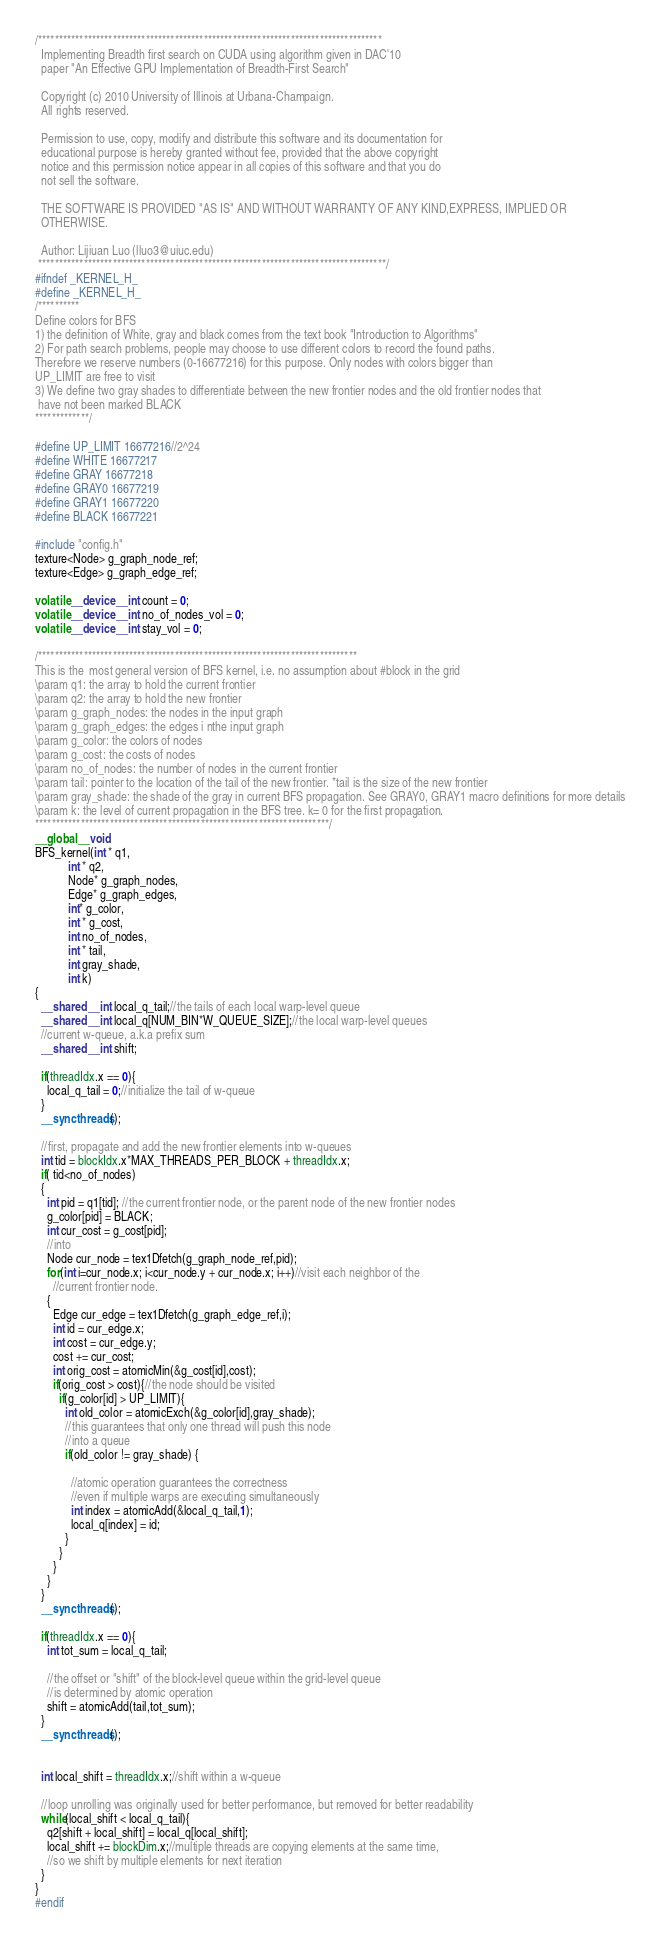<code> <loc_0><loc_0><loc_500><loc_500><_Cuda_>/***********************************************************************************
  Implementing Breadth first search on CUDA using algorithm given in DAC'10
  paper "An Effective GPU Implementation of Breadth-First Search"

  Copyright (c) 2010 University of Illinois at Urbana-Champaign. 
  All rights reserved.

  Permission to use, copy, modify and distribute this software and its documentation for 
  educational purpose is hereby granted without fee, provided that the above copyright 
  notice and this permission notice appear in all copies of this software and that you do 
  not sell the software.

  THE SOFTWARE IS PROVIDED "AS IS" AND WITHOUT WARRANTY OF ANY KIND,EXPRESS, IMPLIED OR 
  OTHERWISE.

  Author: Lijiuan Luo (lluo3@uiuc.edu)
 ************************************************************************************/
#ifndef _KERNEL_H_
#define _KERNEL_H_
/**********
Define colors for BFS
1) the definition of White, gray and black comes from the text book "Introduction to Algorithms"
2) For path search problems, people may choose to use different colors to record the found paths.
Therefore we reserve numbers (0-16677216) for this purpose. Only nodes with colors bigger than
UP_LIMIT are free to visit 
3) We define two gray shades to differentiate between the new frontier nodes and the old frontier nodes that
 have not been marked BLACK 
*************/

#define UP_LIMIT 16677216//2^24
#define WHITE 16677217
#define GRAY 16677218
#define GRAY0 16677219
#define GRAY1 16677220
#define BLACK 16677221

#include "config.h"
texture<Node> g_graph_node_ref;
texture<Edge> g_graph_edge_ref;

volatile __device__ int count = 0;
volatile __device__ int no_of_nodes_vol = 0;
volatile __device__ int stay_vol = 0;

/*****************************************************************************
This is the  most general version of BFS kernel, i.e. no assumption about #block in the grid  
\param q1: the array to hold the current frontier
\param q2: the array to hold the new frontier
\param g_graph_nodes: the nodes in the input graph
\param g_graph_edges: the edges i nthe input graph
\param g_color: the colors of nodes
\param g_cost: the costs of nodes
\param no_of_nodes: the number of nodes in the current frontier
\param tail: pointer to the location of the tail of the new frontier. *tail is the size of the new frontier 
\param gray_shade: the shade of the gray in current BFS propagation. See GRAY0, GRAY1 macro definitions for more details
\param k: the level of current propagation in the BFS tree. k= 0 for the first propagation.
***********************************************************************/
__global__ void
BFS_kernel(int * q1, 
           int * q2, 
           Node* g_graph_nodes, 
           Edge* g_graph_edges, 
           int* g_color, 
           int * g_cost, 
           int no_of_nodes, 
           int * tail, 
           int gray_shade, 
           int k) 
{
  __shared__ int local_q_tail;//the tails of each local warp-level queue
  __shared__ int local_q[NUM_BIN*W_QUEUE_SIZE];//the local warp-level queues 
  //current w-queue, a.k.a prefix sum
  __shared__ int shift;

  if(threadIdx.x == 0){
    local_q_tail = 0;//initialize the tail of w-queue
  }
  __syncthreads();

  //first, propagate and add the new frontier elements into w-queues
  int tid = blockIdx.x*MAX_THREADS_PER_BLOCK + threadIdx.x;
  if( tid<no_of_nodes)
  {
    int pid = q1[tid]; //the current frontier node, or the parent node of the new frontier nodes 
    g_color[pid] = BLACK;
    int cur_cost = g_cost[pid];
    //into
    Node cur_node = tex1Dfetch(g_graph_node_ref,pid);
    for(int i=cur_node.x; i<cur_node.y + cur_node.x; i++)//visit each neighbor of the
      //current frontier node.
    {
      Edge cur_edge = tex1Dfetch(g_graph_edge_ref,i);
      int id = cur_edge.x;
      int cost = cur_edge.y;
      cost += cur_cost;
      int orig_cost = atomicMin(&g_cost[id],cost);
      if(orig_cost > cost){//the node should be visited
        if(g_color[id] > UP_LIMIT){
          int old_color = atomicExch(&g_color[id],gray_shade);
          //this guarantees that only one thread will push this node
          //into a queue
          if(old_color != gray_shade) {

            //atomic operation guarantees the correctness
            //even if multiple warps are executing simultaneously
            int index = atomicAdd(&local_q_tail,1);
            local_q[index] = id;
          }
        }
      }
    }
  }
  __syncthreads();

  if(threadIdx.x == 0){
    int tot_sum = local_q_tail; 

    //the offset or "shift" of the block-level queue within the grid-level queue
    //is determined by atomic operation
    shift = atomicAdd(tail,tot_sum);
  }
  __syncthreads();


  int local_shift = threadIdx.x;//shift within a w-queue

  //loop unrolling was originally used for better performance, but removed for better readability
  while(local_shift < local_q_tail){
    q2[shift + local_shift] = local_q[local_shift];
    local_shift += blockDim.x;//multiple threads are copying elements at the same time,
    //so we shift by multiple elements for next iteration  
  }
}
#endif 
</code> 